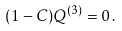Convert formula to latex. <formula><loc_0><loc_0><loc_500><loc_500>( 1 - C ) Q ^ { ( 3 ) } = 0 \, .</formula> 